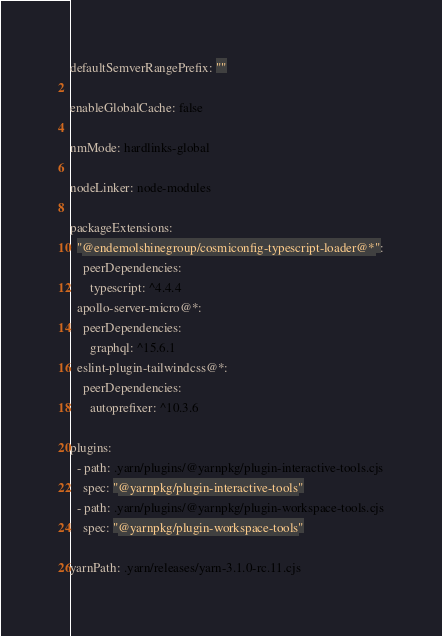<code> <loc_0><loc_0><loc_500><loc_500><_YAML_>defaultSemverRangePrefix: ""

enableGlobalCache: false

nmMode: hardlinks-global

nodeLinker: node-modules

packageExtensions:
  "@endemolshinegroup/cosmiconfig-typescript-loader@*":
    peerDependencies:
      typescript: ^4.4.4
  apollo-server-micro@*:
    peerDependencies:
      graphql: ^15.6.1
  eslint-plugin-tailwindcss@*:
    peerDependencies:
      autoprefixer: ^10.3.6

plugins:
  - path: .yarn/plugins/@yarnpkg/plugin-interactive-tools.cjs
    spec: "@yarnpkg/plugin-interactive-tools"
  - path: .yarn/plugins/@yarnpkg/plugin-workspace-tools.cjs
    spec: "@yarnpkg/plugin-workspace-tools"

yarnPath: .yarn/releases/yarn-3.1.0-rc.11.cjs
</code> 